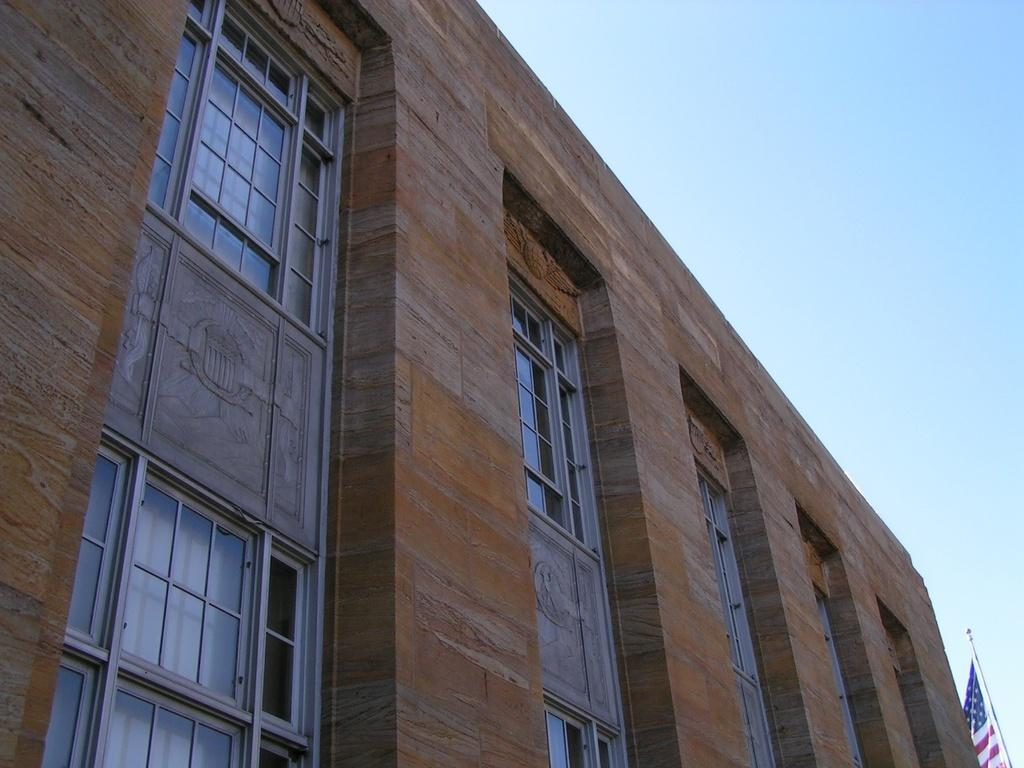What type of structure is present in the image? There is a building in the image. What can be seen on top of the flag post in the image? There is a flag on a flag post in the image. What part of the natural environment is visible in the image? The sky is visible in the image. What type of cake is being served in the image? There is no cake present in the image; it features a building and a flag on a flag post. What process is being carried out in the image? The image does not depict a specific process; it shows a building and a flag on a flag post. 